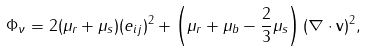<formula> <loc_0><loc_0><loc_500><loc_500>\Phi _ { \nu } = 2 ( \mu _ { r } + \mu _ { s } ) ( e _ { i j } ) ^ { 2 } + \left ( \mu _ { r } + \mu _ { b } - \frac { 2 } { 3 } \mu _ { s } \right ) ( \nabla \cdot \mathbf v ) ^ { 2 } ,</formula> 